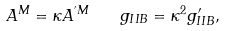<formula> <loc_0><loc_0><loc_500><loc_500>A ^ { M } = \kappa A ^ { ^ { \prime } M } \quad g _ { I I B } = \kappa ^ { 2 } g ^ { \prime } _ { I I B } ,</formula> 